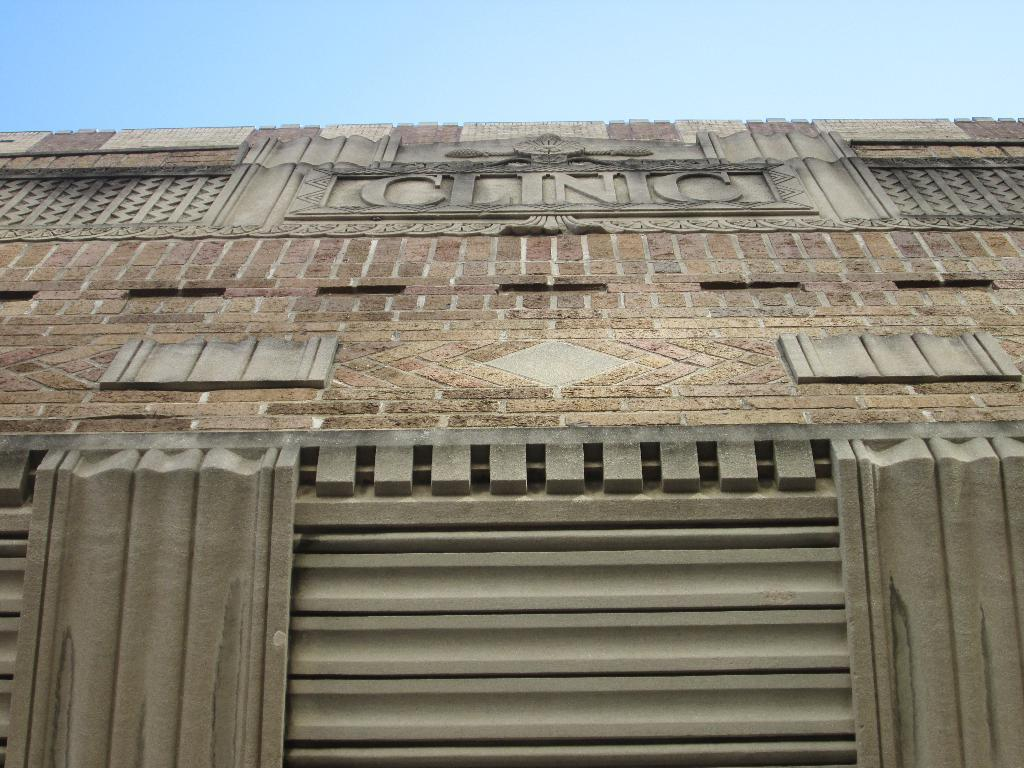What type of structure is visible in the image? There is a building in the image. What can be seen on the building? There is text on the building. What type of wine is being served in the image? There is no wine present in the image; it only features a building with text on it. 